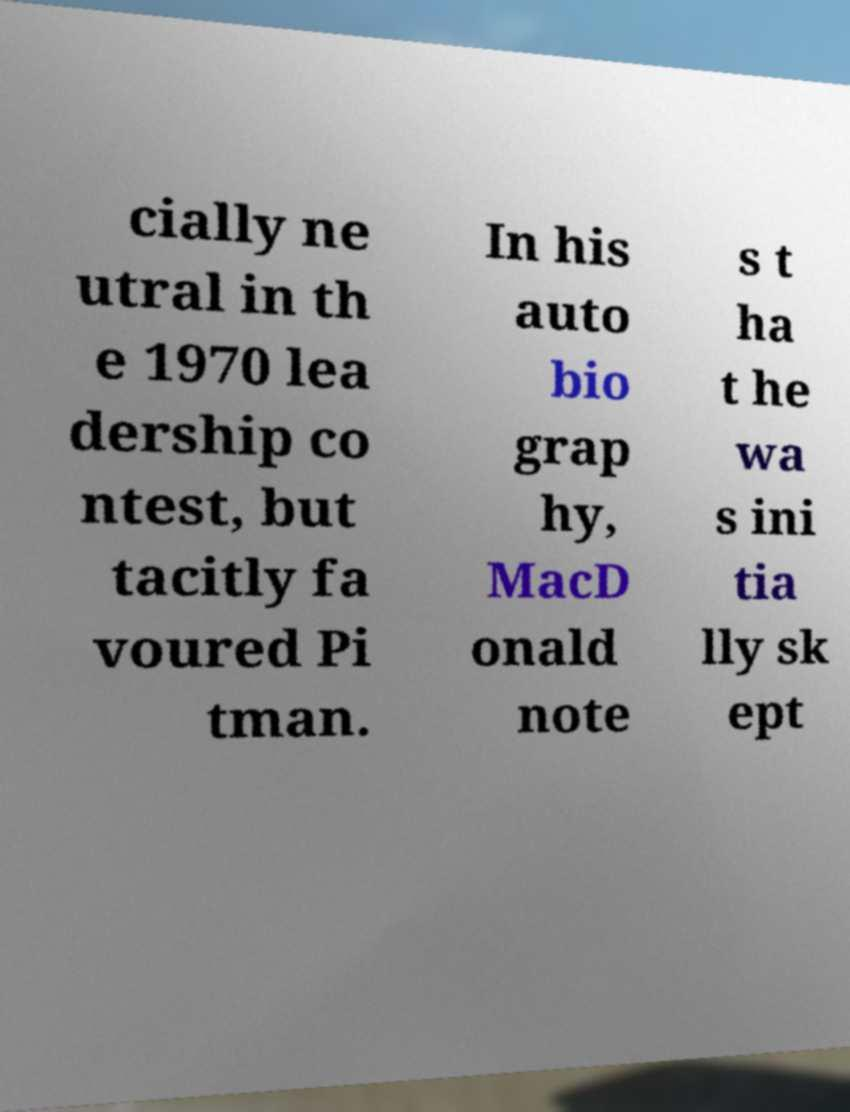Please read and relay the text visible in this image. What does it say? cially ne utral in th e 1970 lea dership co ntest, but tacitly fa voured Pi tman. In his auto bio grap hy, MacD onald note s t ha t he wa s ini tia lly sk ept 